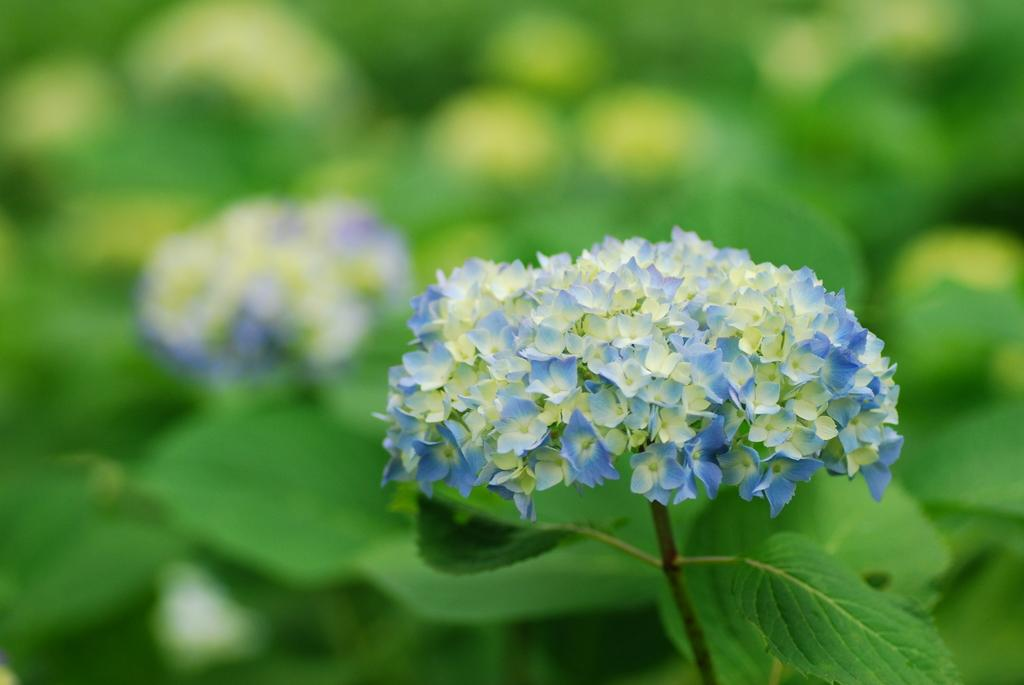What type of plants can be seen in the image? There are flowers and green leaves in the image. Can you describe the color of the flowers? The provided facts do not mention the color of the flowers. What is the color of the leaves in the image? The leaves in the image are green. What type of calculator can be seen in the image? There is no calculator present in the image. What type of tree is visible in the image? The provided facts do not mention any trees in the image. 